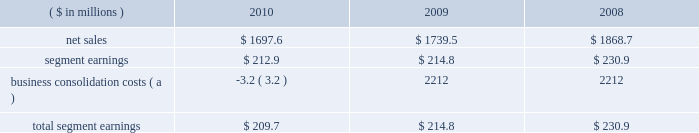Page 20 of 100 segment sales were $ 100.7 million lower in 2009 than in 2008 , primarily as a result of the impact of lower aluminum prices partially offset by an increase in sales volumes .
The higher sales volumes in 2009 were the result of incremental volumes from the four plants purchased from ab inbev , partially offset by certain plant closures and lower sales volumes in the existing business .
Segment earnings in 2010 were $ 122.3 million higher than in 2009 primarily due to a net $ 85 million impact related to the higher sales volumes and $ 45 million of product mix and improved manufacturing performance associated with higher production .
Also adding to the 2010 improvement was the effect of a $ 7 million out-of-period inventory charge in 2009 .
The details of the out-of-period adjustment are included in note 7 to the consolidated financial statements included within item 8 of this report .
Segment earnings in 2009 were higher than in 2008 due to $ 12 million of earnings contribution from the four acquired plants and approximately $ 21 million of savings associated with plant closures .
Partially offsetting these favorable impacts were lower carbonated soft drink and beer can sales volumes ( excluding the newly acquired plants ) and approximately $ 25 million related to higher cost inventories in the first half of 2009 .
Metal beverage packaging , europe .
( a ) further details of these items are included in note 5 to the consolidated financial statements within item 8 of this report .
The metal beverage packaging , europe , segment includes metal beverage packaging products manufactured in europe .
Ball packaging europe has manufacturing plants located in germany , the united kingdom , france , the netherlands , poland and serbia , and is the second largest metal beverage container business in europe .
Segment sales in 2010 decreased $ 41.9 million compared to 2009 , primarily due to unfavorable foreign exchange effects of $ 93 million and price and mix changes , partially offset by higher sales volumes .
Segment sales in 2009 as compared to 2008 were $ 129.2 million lower due to $ 110 million of unfavorable foreign exchange effects , partially offset by better commercial terms .
Sales volumes in 2009 were essentially flat compared to those in the prior year .
Segment earnings in 2010 decreased $ 1.9 million compared to 2009 , primarily the result of a $ 28 million increase related to higher sales volumes , offset by $ 18 million of negative effects from foreign currency translation and $ 12 million of higher inventory and other costs .
While 2009 sales volumes were consistent with the prior year , the adverse effects of foreign currency translation , both within europe and on the conversion of the euro to the u.s .
Dollar , reduced segment earnings by $ 8 million .
Also contributing to lower segment earnings were higher cost inventory carried into 2009 and a change in sales mix , partially offset by better commercial terms in some of our contracts .
On january 18 , 2011 , ball acquired aerocan s.a.s .
( aerocan ) , a leading european supplier of aluminum aerosol cans and bottles , for 20ac222.4 million ( approximately $ 300 million ) in cash and assumed debt .
Aerocan manufactures extruded aluminum aerosol cans and bottles , and the aluminum slugs used to make them , for customers in the personal care , pharmaceutical , beverage and food industries .
It operates three aerosol can manufacturing plants 2013 one each in the czech republic , france and the united kingdom 2013 and is a 51 percent owner of a joint venture aluminum slug plant in france .
The four plants employ approximately 560 people .
The acquisition of aerocan will allow ball to enter a growing part of the metal packaging industry and to broaden the company 2019s market development efforts into a new customer base. .
What would the increase in segment earnings for 2010 have been without the higher sales volumes ( in millions ) ? 
Computations: (122.3 - 85)
Answer: 37.3. Page 20 of 100 segment sales were $ 100.7 million lower in 2009 than in 2008 , primarily as a result of the impact of lower aluminum prices partially offset by an increase in sales volumes .
The higher sales volumes in 2009 were the result of incremental volumes from the four plants purchased from ab inbev , partially offset by certain plant closures and lower sales volumes in the existing business .
Segment earnings in 2010 were $ 122.3 million higher than in 2009 primarily due to a net $ 85 million impact related to the higher sales volumes and $ 45 million of product mix and improved manufacturing performance associated with higher production .
Also adding to the 2010 improvement was the effect of a $ 7 million out-of-period inventory charge in 2009 .
The details of the out-of-period adjustment are included in note 7 to the consolidated financial statements included within item 8 of this report .
Segment earnings in 2009 were higher than in 2008 due to $ 12 million of earnings contribution from the four acquired plants and approximately $ 21 million of savings associated with plant closures .
Partially offsetting these favorable impacts were lower carbonated soft drink and beer can sales volumes ( excluding the newly acquired plants ) and approximately $ 25 million related to higher cost inventories in the first half of 2009 .
Metal beverage packaging , europe .
( a ) further details of these items are included in note 5 to the consolidated financial statements within item 8 of this report .
The metal beverage packaging , europe , segment includes metal beverage packaging products manufactured in europe .
Ball packaging europe has manufacturing plants located in germany , the united kingdom , france , the netherlands , poland and serbia , and is the second largest metal beverage container business in europe .
Segment sales in 2010 decreased $ 41.9 million compared to 2009 , primarily due to unfavorable foreign exchange effects of $ 93 million and price and mix changes , partially offset by higher sales volumes .
Segment sales in 2009 as compared to 2008 were $ 129.2 million lower due to $ 110 million of unfavorable foreign exchange effects , partially offset by better commercial terms .
Sales volumes in 2009 were essentially flat compared to those in the prior year .
Segment earnings in 2010 decreased $ 1.9 million compared to 2009 , primarily the result of a $ 28 million increase related to higher sales volumes , offset by $ 18 million of negative effects from foreign currency translation and $ 12 million of higher inventory and other costs .
While 2009 sales volumes were consistent with the prior year , the adverse effects of foreign currency translation , both within europe and on the conversion of the euro to the u.s .
Dollar , reduced segment earnings by $ 8 million .
Also contributing to lower segment earnings were higher cost inventory carried into 2009 and a change in sales mix , partially offset by better commercial terms in some of our contracts .
On january 18 , 2011 , ball acquired aerocan s.a.s .
( aerocan ) , a leading european supplier of aluminum aerosol cans and bottles , for 20ac222.4 million ( approximately $ 300 million ) in cash and assumed debt .
Aerocan manufactures extruded aluminum aerosol cans and bottles , and the aluminum slugs used to make them , for customers in the personal care , pharmaceutical , beverage and food industries .
It operates three aerosol can manufacturing plants 2013 one each in the czech republic , france and the united kingdom 2013 and is a 51 percent owner of a joint venture aluminum slug plant in france .
The four plants employ approximately 560 people .
The acquisition of aerocan will allow ball to enter a growing part of the metal packaging industry and to broaden the company 2019s market development efforts into a new customer base. .
The segment sales decrease in 2010 was what percent of the decrease in 2009? 
Computations: ((129.2 - 41.9) / 129.2)
Answer: 0.6757. Page 20 of 100 segment sales were $ 100.7 million lower in 2009 than in 2008 , primarily as a result of the impact of lower aluminum prices partially offset by an increase in sales volumes .
The higher sales volumes in 2009 were the result of incremental volumes from the four plants purchased from ab inbev , partially offset by certain plant closures and lower sales volumes in the existing business .
Segment earnings in 2010 were $ 122.3 million higher than in 2009 primarily due to a net $ 85 million impact related to the higher sales volumes and $ 45 million of product mix and improved manufacturing performance associated with higher production .
Also adding to the 2010 improvement was the effect of a $ 7 million out-of-period inventory charge in 2009 .
The details of the out-of-period adjustment are included in note 7 to the consolidated financial statements included within item 8 of this report .
Segment earnings in 2009 were higher than in 2008 due to $ 12 million of earnings contribution from the four acquired plants and approximately $ 21 million of savings associated with plant closures .
Partially offsetting these favorable impacts were lower carbonated soft drink and beer can sales volumes ( excluding the newly acquired plants ) and approximately $ 25 million related to higher cost inventories in the first half of 2009 .
Metal beverage packaging , europe .
( a ) further details of these items are included in note 5 to the consolidated financial statements within item 8 of this report .
The metal beverage packaging , europe , segment includes metal beverage packaging products manufactured in europe .
Ball packaging europe has manufacturing plants located in germany , the united kingdom , france , the netherlands , poland and serbia , and is the second largest metal beverage container business in europe .
Segment sales in 2010 decreased $ 41.9 million compared to 2009 , primarily due to unfavorable foreign exchange effects of $ 93 million and price and mix changes , partially offset by higher sales volumes .
Segment sales in 2009 as compared to 2008 were $ 129.2 million lower due to $ 110 million of unfavorable foreign exchange effects , partially offset by better commercial terms .
Sales volumes in 2009 were essentially flat compared to those in the prior year .
Segment earnings in 2010 decreased $ 1.9 million compared to 2009 , primarily the result of a $ 28 million increase related to higher sales volumes , offset by $ 18 million of negative effects from foreign currency translation and $ 12 million of higher inventory and other costs .
While 2009 sales volumes were consistent with the prior year , the adverse effects of foreign currency translation , both within europe and on the conversion of the euro to the u.s .
Dollar , reduced segment earnings by $ 8 million .
Also contributing to lower segment earnings were higher cost inventory carried into 2009 and a change in sales mix , partially offset by better commercial terms in some of our contracts .
On january 18 , 2011 , ball acquired aerocan s.a.s .
( aerocan ) , a leading european supplier of aluminum aerosol cans and bottles , for 20ac222.4 million ( approximately $ 300 million ) in cash and assumed debt .
Aerocan manufactures extruded aluminum aerosol cans and bottles , and the aluminum slugs used to make them , for customers in the personal care , pharmaceutical , beverage and food industries .
It operates three aerosol can manufacturing plants 2013 one each in the czech republic , france and the united kingdom 2013 and is a 51 percent owner of a joint venture aluminum slug plant in france .
The four plants employ approximately 560 people .
The acquisition of aerocan will allow ball to enter a growing part of the metal packaging industry and to broaden the company 2019s market development efforts into a new customer base. .
What was the percentage change in net sales metal beverage packaging , europe between 2008 to 2009? 
Computations: ((1739.5 - 1868.7) / 1868.7)
Answer: -0.06914. 